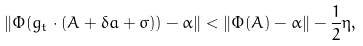<formula> <loc_0><loc_0><loc_500><loc_500>\| \Phi ( g _ { t } \cdot ( A + \delta a + \sigma ) ) - \alpha \| < \| \Phi ( A ) - \alpha \| - \frac { 1 } { 2 } \eta ,</formula> 